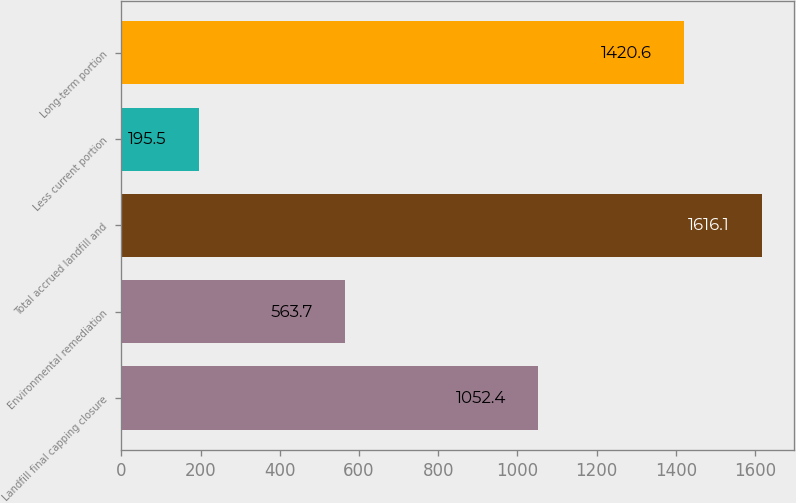<chart> <loc_0><loc_0><loc_500><loc_500><bar_chart><fcel>Landfill final capping closure<fcel>Environmental remediation<fcel>Total accrued landfill and<fcel>Less current portion<fcel>Long-term portion<nl><fcel>1052.4<fcel>563.7<fcel>1616.1<fcel>195.5<fcel>1420.6<nl></chart> 